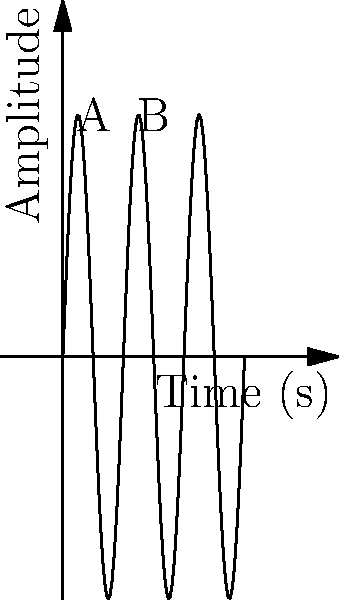As a DJ, you're analyzing a sound wave to incorporate into your mix. The graph shows the amplitude of a sound wave over time. Given that the distance between points A and B represents one complete cycle and the maximum amplitude is 2 units, determine the frequency of this sound wave in Hertz (Hz). To find the frequency of the sound wave, we need to follow these steps:

1) First, we need to determine the period (T) of the wave. The period is the time it takes for one complete cycle.
   From the graph, we can see that one cycle occurs between points A and B.
   The x-axis represents time in seconds, and the distance between A and B is 0.5 seconds.
   So, $T = 0.5$ seconds.

2) The frequency (f) is the reciprocal of the period. The formula for frequency is:

   $f = \frac{1}{T}$

3) Substituting our value for T:

   $f = \frac{1}{0.5}$ Hz

4) Simplifying:

   $f = 2$ Hz

Note: The amplitude (2 units) doesn't affect the frequency calculation, but it's useful information for other sound wave characteristics.
Answer: 2 Hz 